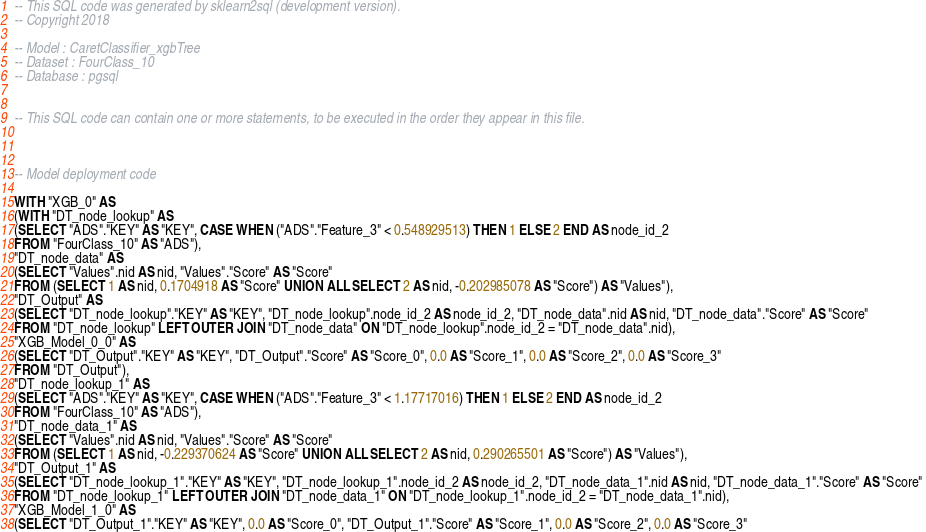Convert code to text. <code><loc_0><loc_0><loc_500><loc_500><_SQL_>-- This SQL code was generated by sklearn2sql (development version).
-- Copyright 2018

-- Model : CaretClassifier_xgbTree
-- Dataset : FourClass_10
-- Database : pgsql


-- This SQL code can contain one or more statements, to be executed in the order they appear in this file.



-- Model deployment code

WITH "XGB_0" AS 
(WITH "DT_node_lookup" AS 
(SELECT "ADS"."KEY" AS "KEY", CASE WHEN ("ADS"."Feature_3" < 0.548929513) THEN 1 ELSE 2 END AS node_id_2 
FROM "FourClass_10" AS "ADS"), 
"DT_node_data" AS 
(SELECT "Values".nid AS nid, "Values"."Score" AS "Score" 
FROM (SELECT 1 AS nid, 0.1704918 AS "Score" UNION ALL SELECT 2 AS nid, -0.202985078 AS "Score") AS "Values"), 
"DT_Output" AS 
(SELECT "DT_node_lookup"."KEY" AS "KEY", "DT_node_lookup".node_id_2 AS node_id_2, "DT_node_data".nid AS nid, "DT_node_data"."Score" AS "Score" 
FROM "DT_node_lookup" LEFT OUTER JOIN "DT_node_data" ON "DT_node_lookup".node_id_2 = "DT_node_data".nid), 
"XGB_Model_0_0" AS 
(SELECT "DT_Output"."KEY" AS "KEY", "DT_Output"."Score" AS "Score_0", 0.0 AS "Score_1", 0.0 AS "Score_2", 0.0 AS "Score_3" 
FROM "DT_Output"), 
"DT_node_lookup_1" AS 
(SELECT "ADS"."KEY" AS "KEY", CASE WHEN ("ADS"."Feature_3" < 1.17717016) THEN 1 ELSE 2 END AS node_id_2 
FROM "FourClass_10" AS "ADS"), 
"DT_node_data_1" AS 
(SELECT "Values".nid AS nid, "Values"."Score" AS "Score" 
FROM (SELECT 1 AS nid, -0.229370624 AS "Score" UNION ALL SELECT 2 AS nid, 0.290265501 AS "Score") AS "Values"), 
"DT_Output_1" AS 
(SELECT "DT_node_lookup_1"."KEY" AS "KEY", "DT_node_lookup_1".node_id_2 AS node_id_2, "DT_node_data_1".nid AS nid, "DT_node_data_1"."Score" AS "Score" 
FROM "DT_node_lookup_1" LEFT OUTER JOIN "DT_node_data_1" ON "DT_node_lookup_1".node_id_2 = "DT_node_data_1".nid), 
"XGB_Model_1_0" AS 
(SELECT "DT_Output_1"."KEY" AS "KEY", 0.0 AS "Score_0", "DT_Output_1"."Score" AS "Score_1", 0.0 AS "Score_2", 0.0 AS "Score_3" </code> 